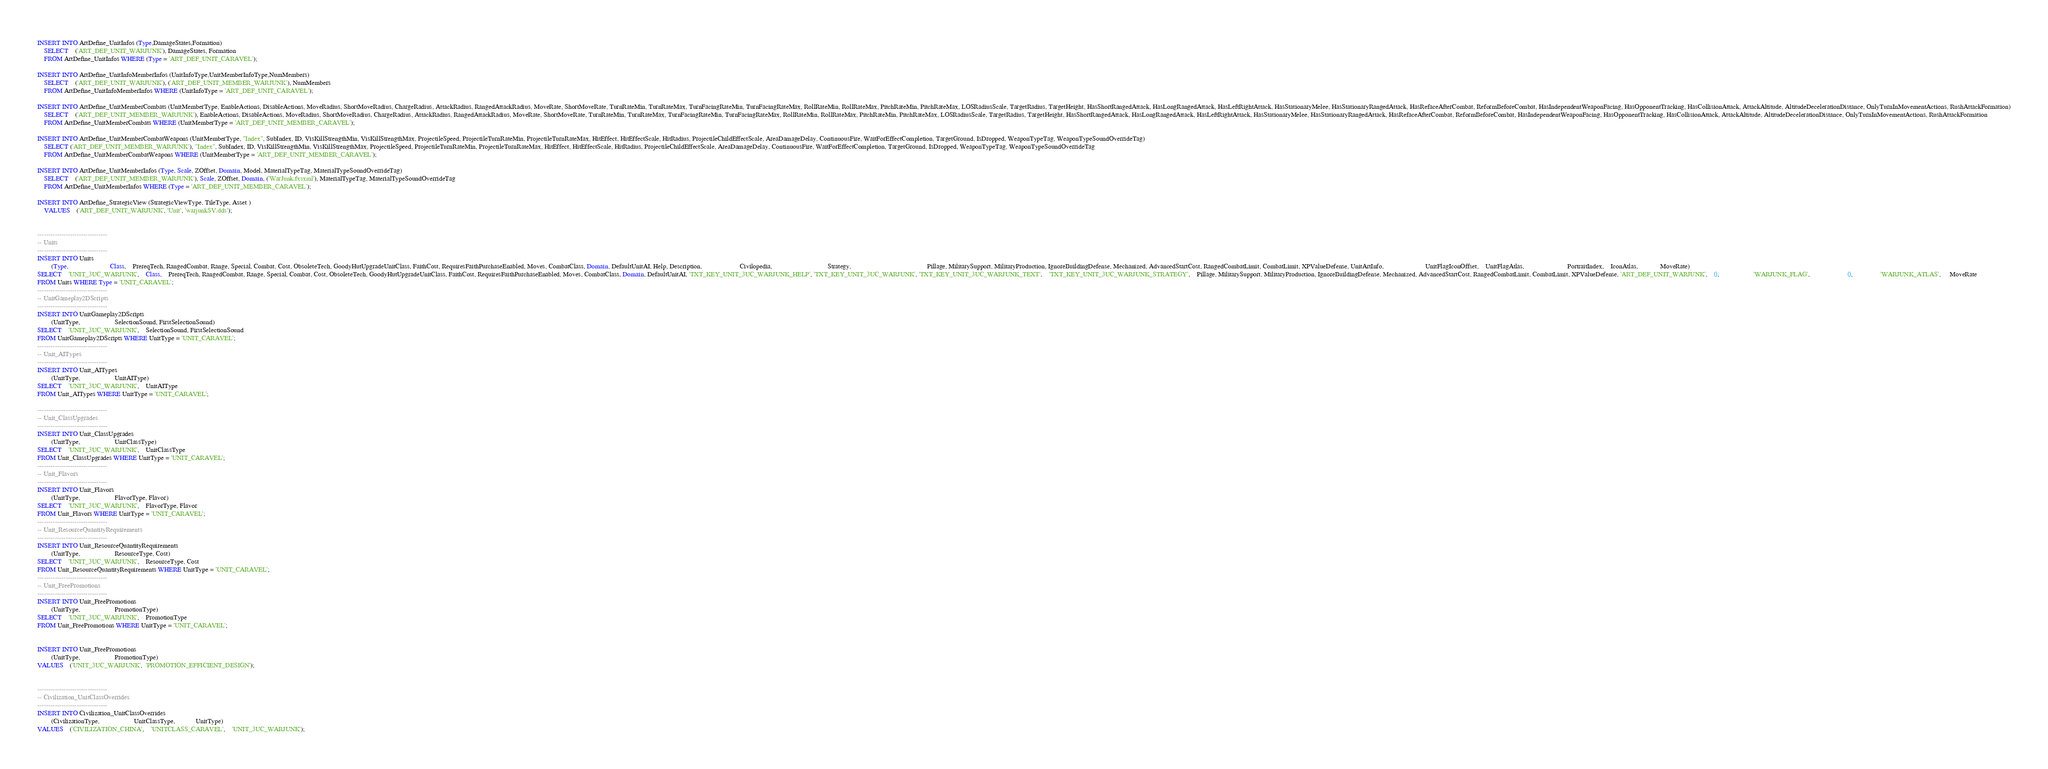<code> <loc_0><loc_0><loc_500><loc_500><_SQL_>INSERT INTO ArtDefine_UnitInfos (Type,DamageStates,Formation)
	SELECT	('ART_DEF_UNIT_WARJUNK'), DamageStates, Formation
	FROM ArtDefine_UnitInfos WHERE (Type = 'ART_DEF_UNIT_CARAVEL');

INSERT INTO ArtDefine_UnitInfoMemberInfos (UnitInfoType,UnitMemberInfoType,NumMembers)
	SELECT	('ART_DEF_UNIT_WARJUNK'), ('ART_DEF_UNIT_MEMBER_WARJUNK'), NumMembers
	FROM ArtDefine_UnitInfoMemberInfos WHERE (UnitInfoType = 'ART_DEF_UNIT_CARAVEL');

INSERT INTO ArtDefine_UnitMemberCombats (UnitMemberType, EnableActions, DisableActions, MoveRadius, ShortMoveRadius, ChargeRadius, AttackRadius, RangedAttackRadius, MoveRate, ShortMoveRate, TurnRateMin, TurnRateMax, TurnFacingRateMin, TurnFacingRateMax, RollRateMin, RollRateMax, PitchRateMin, PitchRateMax, LOSRadiusScale, TargetRadius, TargetHeight, HasShortRangedAttack, HasLongRangedAttack, HasLeftRightAttack, HasStationaryMelee, HasStationaryRangedAttack, HasRefaceAfterCombat, ReformBeforeCombat, HasIndependentWeaponFacing, HasOpponentTracking, HasCollisionAttack, AttackAltitude, AltitudeDecelerationDistance, OnlyTurnInMovementActions, RushAttackFormation)
	SELECT	('ART_DEF_UNIT_MEMBER_WARJUNK'), EnableActions, DisableActions, MoveRadius, ShortMoveRadius, ChargeRadius, AttackRadius, RangedAttackRadius, MoveRate, ShortMoveRate, TurnRateMin, TurnRateMax, TurnFacingRateMin, TurnFacingRateMax, RollRateMin, RollRateMax, PitchRateMin, PitchRateMax, LOSRadiusScale, TargetRadius, TargetHeight, HasShortRangedAttack, HasLongRangedAttack, HasLeftRightAttack, HasStationaryMelee, HasStationaryRangedAttack, HasRefaceAfterCombat, ReformBeforeCombat, HasIndependentWeaponFacing, HasOpponentTracking, HasCollisionAttack, AttackAltitude, AltitudeDecelerationDistance, OnlyTurnInMovementActions, RushAttackFormation
	FROM ArtDefine_UnitMemberCombats WHERE (UnitMemberType = 'ART_DEF_UNIT_MEMBER_CARAVEL');

INSERT INTO ArtDefine_UnitMemberCombatWeapons (UnitMemberType, "Index", SubIndex, ID, VisKillStrengthMin, VisKillStrengthMax, ProjectileSpeed, ProjectileTurnRateMin, ProjectileTurnRateMax, HitEffect, HitEffectScale, HitRadius, ProjectileChildEffectScale, AreaDamageDelay, ContinuousFire, WaitForEffectCompletion, TargetGround, IsDropped, WeaponTypeTag, WeaponTypeSoundOverrideTag)
	SELECT ('ART_DEF_UNIT_MEMBER_WARJUNK'), "Index", SubIndex, ID, VisKillStrengthMin, VisKillStrengthMax, ProjectileSpeed, ProjectileTurnRateMin, ProjectileTurnRateMax, HitEffect, HitEffectScale, HitRadius, ProjectileChildEffectScale, AreaDamageDelay, ContinuousFire, WaitForEffectCompletion, TargetGround, IsDropped, WeaponTypeTag, WeaponTypeSoundOverrideTag
	FROM ArtDefine_UnitMemberCombatWeapons WHERE (UnitMemberType = 'ART_DEF_UNIT_MEMBER_CARAVEL');

INSERT INTO ArtDefine_UnitMemberInfos (Type, Scale, ZOffset, Domain, Model, MaterialTypeTag, MaterialTypeSoundOverrideTag)
	SELECT	('ART_DEF_UNIT_MEMBER_WARJUNK'), Scale, ZOffset, Domain, ('WarJunk.fxsxml'), MaterialTypeTag, MaterialTypeSoundOverrideTag
	FROM ArtDefine_UnitMemberInfos WHERE (Type = 'ART_DEF_UNIT_MEMBER_CARAVEL');

INSERT INTO ArtDefine_StrategicView (StrategicViewType, TileType, Asset )
	VALUES	('ART_DEF_UNIT_WARJUNK', 'Unit', 'warjunkSV.dds');


--------------------------------	
-- Units
--------------------------------
INSERT INTO Units 	
		(Type, 						Class,	PrereqTech, RangedCombat, Range, Special, Combat, Cost, ObsoleteTech, GoodyHutUpgradeUnitClass, FaithCost, RequiresFaithPurchaseEnabled, Moves, CombatClass, Domain, DefaultUnitAI, Help, Description, 					  Civilopedia, 								Strategy, 		 									Pillage, MilitarySupport, MilitaryProduction, IgnoreBuildingDefense, Mechanized, AdvancedStartCost, RangedCombatLimit, CombatLimit, XPValueDefense, UnitArtInfo, 						UnitFlagIconOffset,	UnitFlagAtlas,						 PortraitIndex, 	IconAtlas,			 MoveRate)
SELECT	'UNIT_3UC_WARJUNK',	Class,	PrereqTech, RangedCombat, Range, Special, Combat, Cost, ObsoleteTech, GoodyHutUpgradeUnitClass, FaithCost, RequiresFaithPurchaseEnabled, Moves, CombatClass, Domain, DefaultUnitAI, 'TXT_KEY_UNIT_3UC_WARJUNK_HELP', 'TXT_KEY_UNIT_3UC_WARJUNK', 'TXT_KEY_UNIT_3UC_WARJUNK_TEXT',	'TXT_KEY_UNIT_3UC_WARJUNK_STRATEGY',  	Pillage, MilitarySupport, MilitaryProduction, IgnoreBuildingDefense, Mechanized, AdvancedStartCost, RangedCombatLimit, CombatLimit, XPValueDefense, 'ART_DEF_UNIT_WARJUNK',	0,					'WARJUNK_FLAG',					  0, 				'WARJUNK_ATLAS',	 MoveRate
FROM Units WHERE Type = 'UNIT_CARAVEL';
--------------------------------	
-- UnitGameplay2DScripts
--------------------------------		
INSERT INTO UnitGameplay2DScripts 	
		(UnitType, 					SelectionSound, FirstSelectionSound)
SELECT	'UNIT_3UC_WARJUNK', 	SelectionSound, FirstSelectionSound
FROM UnitGameplay2DScripts WHERE UnitType = 'UNIT_CARAVEL';
--------------------------------		
-- Unit_AITypes
--------------------------------		
INSERT INTO Unit_AITypes 	
		(UnitType, 					UnitAIType)
SELECT	'UNIT_3UC_WARJUNK', 	UnitAIType
FROM Unit_AITypes WHERE UnitType = 'UNIT_CARAVEL';

--------------------------------	
-- Unit_ClassUpgrades
--------------------------------	
INSERT INTO Unit_ClassUpgrades 	
		(UnitType, 					UnitClassType)
SELECT	'UNIT_3UC_WARJUNK',	UnitClassType
FROM Unit_ClassUpgrades WHERE UnitType = 'UNIT_CARAVEL';	
--------------------------------	
-- Unit_Flavors
--------------------------------		
INSERT INTO Unit_Flavors 	
		(UnitType, 					FlavorType, Flavor)
SELECT	'UNIT_3UC_WARJUNK', 	FlavorType, Flavor
FROM Unit_Flavors WHERE UnitType = 'UNIT_CARAVEL';
--------------------------------	
-- Unit_ResourceQuantityRequirements
--------------------------------	
INSERT INTO Unit_ResourceQuantityRequirements 	
		(UnitType, 					ResourceType, Cost)
SELECT	'UNIT_3UC_WARJUNK', 	ResourceType, Cost
FROM Unit_ResourceQuantityRequirements WHERE UnitType = 'UNIT_CARAVEL';
--------------------------------	
-- Unit_FreePromotions
--------------------------------	
INSERT INTO Unit_FreePromotions 	
		(UnitType, 					PromotionType)
SELECT	'UNIT_3UC_WARJUNK', 	PromotionType
FROM Unit_FreePromotions WHERE UnitType = 'UNIT_CARAVEL';	


INSERT INTO Unit_FreePromotions
		(UnitType, 					PromotionType)
VALUES	('UNIT_3UC_WARJUNK',  'PROMOTION_EFFICIENT_DESIGN');


--------------------------------	
-- Civilization_UnitClassOverrides 
--------------------------------		
INSERT INTO Civilization_UnitClassOverrides 
		(CivilizationType, 					UnitClassType, 			UnitType)
VALUES	('CIVILIZATION_CHINA',	'UNITCLASS_CARAVEL',	'UNIT_3UC_WARJUNK');</code> 